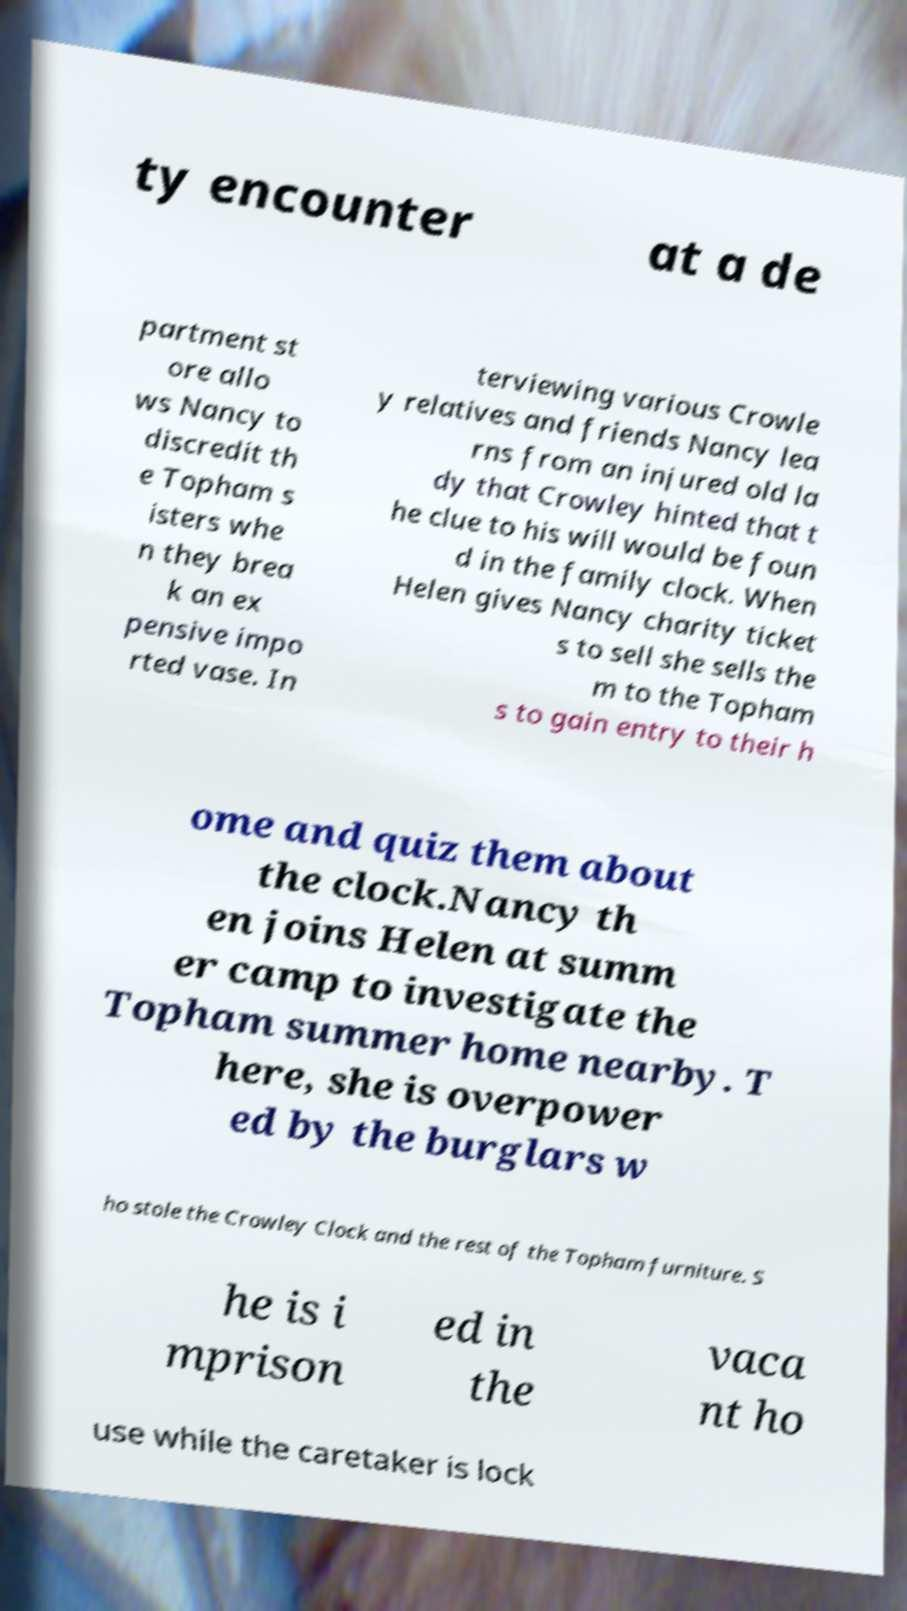Please read and relay the text visible in this image. What does it say? ty encounter at a de partment st ore allo ws Nancy to discredit th e Topham s isters whe n they brea k an ex pensive impo rted vase. In terviewing various Crowle y relatives and friends Nancy lea rns from an injured old la dy that Crowley hinted that t he clue to his will would be foun d in the family clock. When Helen gives Nancy charity ticket s to sell she sells the m to the Topham s to gain entry to their h ome and quiz them about the clock.Nancy th en joins Helen at summ er camp to investigate the Topham summer home nearby. T here, she is overpower ed by the burglars w ho stole the Crowley Clock and the rest of the Topham furniture. S he is i mprison ed in the vaca nt ho use while the caretaker is lock 